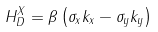<formula> <loc_0><loc_0><loc_500><loc_500>H _ { D } ^ { X } = \beta \left ( { \sigma _ { x } k _ { x } - \sigma _ { y } k _ { y } } \right )</formula> 